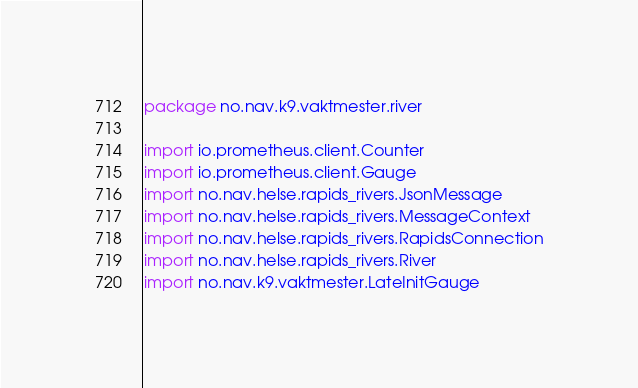<code> <loc_0><loc_0><loc_500><loc_500><_Kotlin_>package no.nav.k9.vaktmester.river

import io.prometheus.client.Counter
import io.prometheus.client.Gauge
import no.nav.helse.rapids_rivers.JsonMessage
import no.nav.helse.rapids_rivers.MessageContext
import no.nav.helse.rapids_rivers.RapidsConnection
import no.nav.helse.rapids_rivers.River
import no.nav.k9.vaktmester.LateInitGauge</code> 